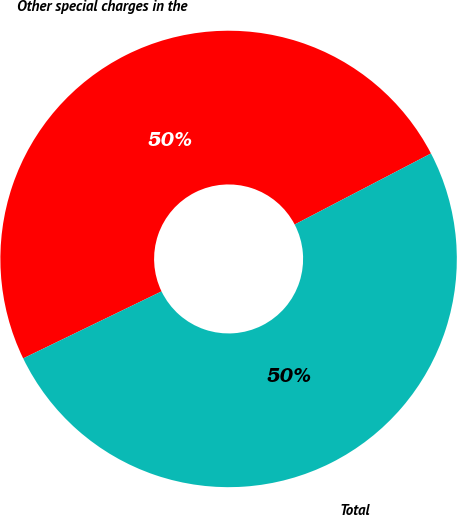Convert chart to OTSL. <chart><loc_0><loc_0><loc_500><loc_500><pie_chart><fcel>Other special charges in the<fcel>Total<nl><fcel>49.53%<fcel>50.47%<nl></chart> 